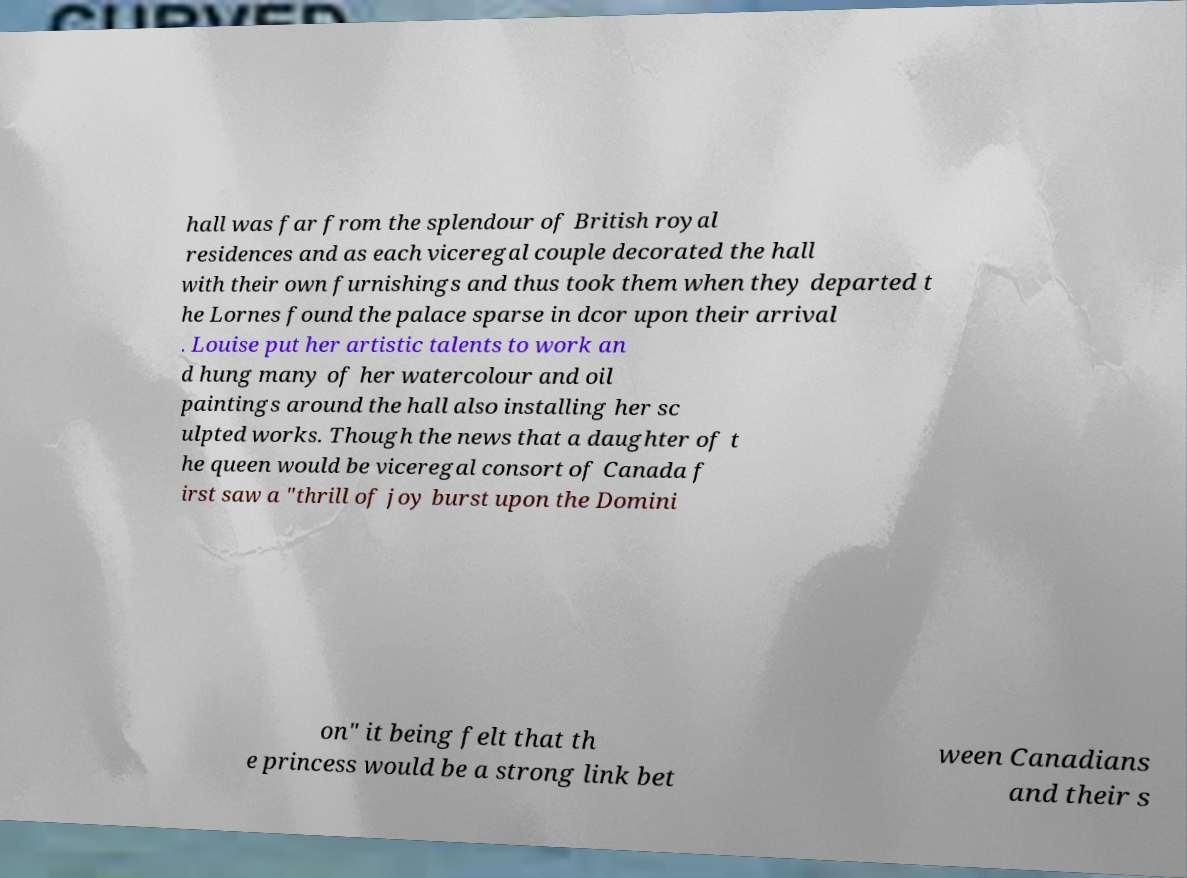What messages or text are displayed in this image? I need them in a readable, typed format. hall was far from the splendour of British royal residences and as each viceregal couple decorated the hall with their own furnishings and thus took them when they departed t he Lornes found the palace sparse in dcor upon their arrival . Louise put her artistic talents to work an d hung many of her watercolour and oil paintings around the hall also installing her sc ulpted works. Though the news that a daughter of t he queen would be viceregal consort of Canada f irst saw a "thrill of joy burst upon the Domini on" it being felt that th e princess would be a strong link bet ween Canadians and their s 